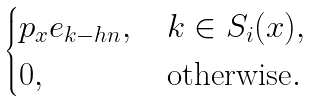<formula> <loc_0><loc_0><loc_500><loc_500>\begin{cases} p _ { x } e _ { k - h n } , \, & k \in S _ { i } ( x ) , \\ 0 , \, & \text {otherwise} . \end{cases}</formula> 